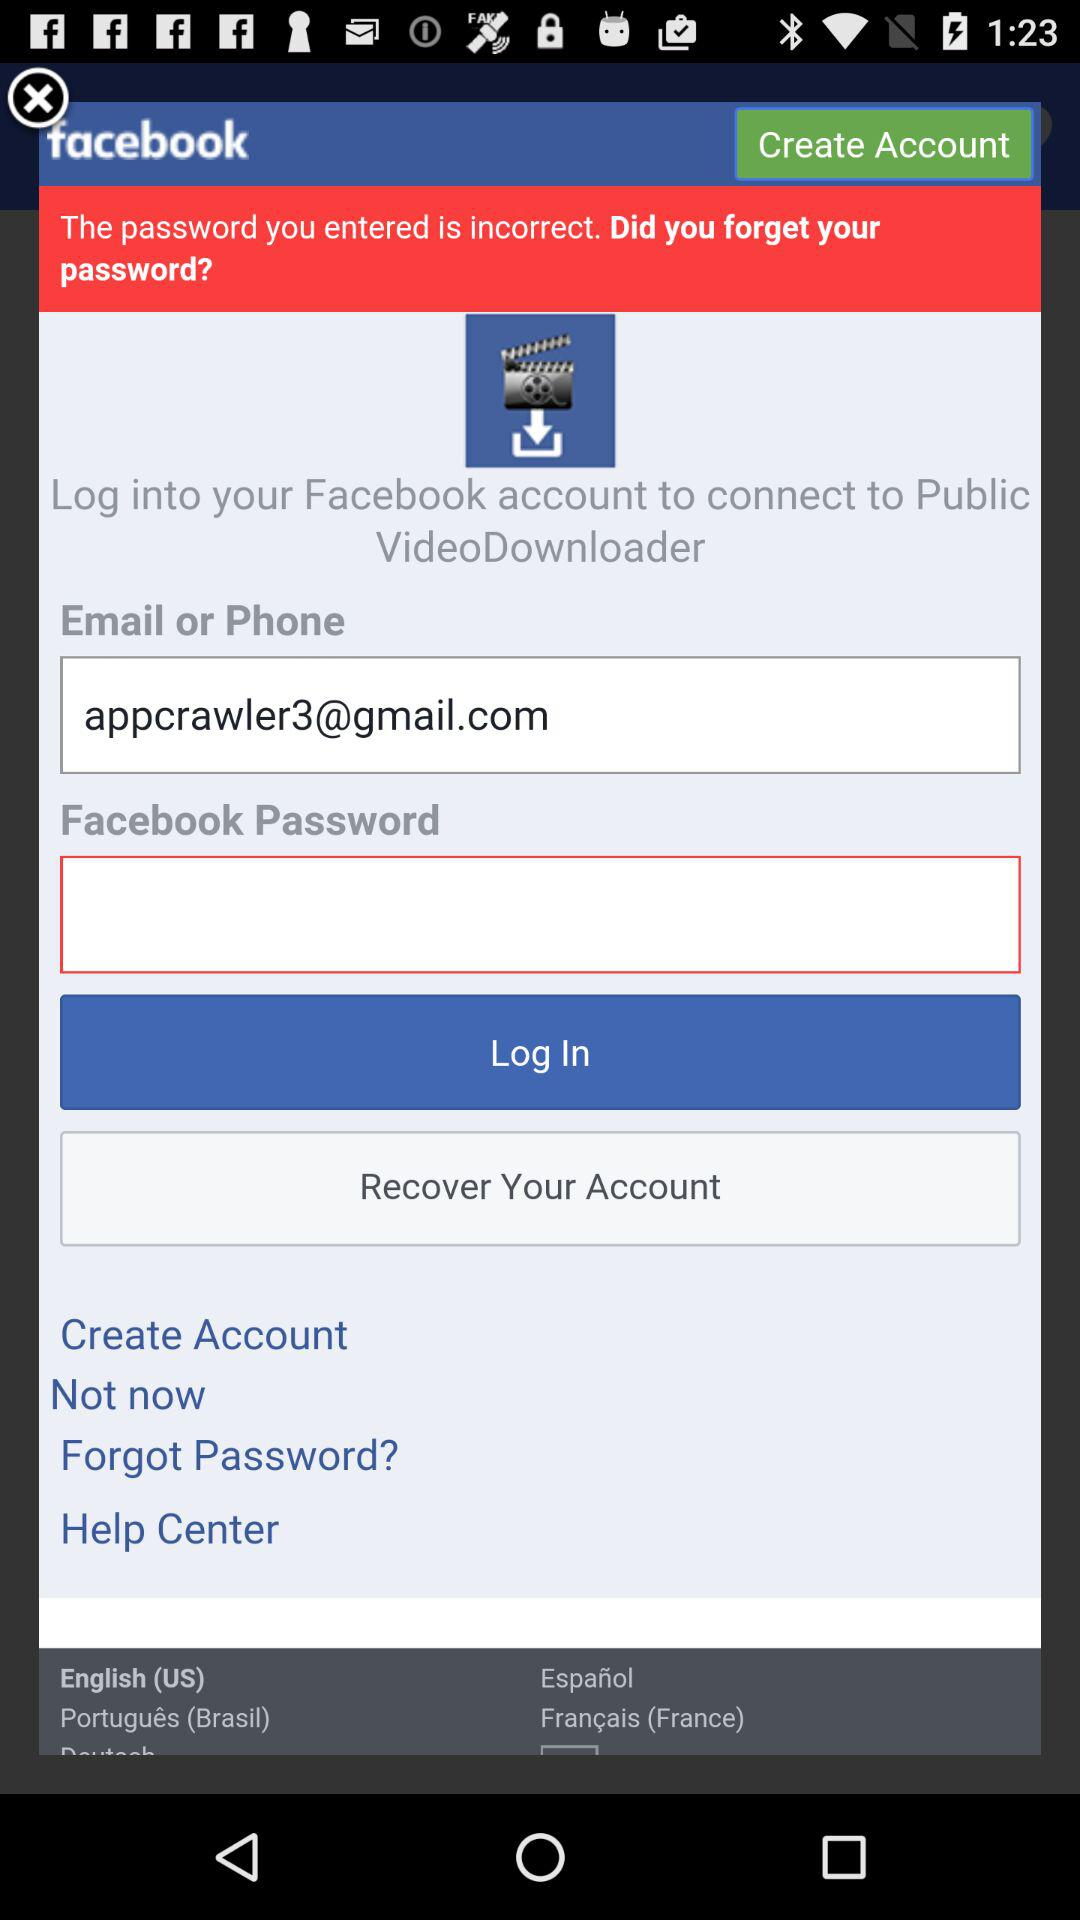What is the email address? The email address is appcrawler3@gmail.com. 